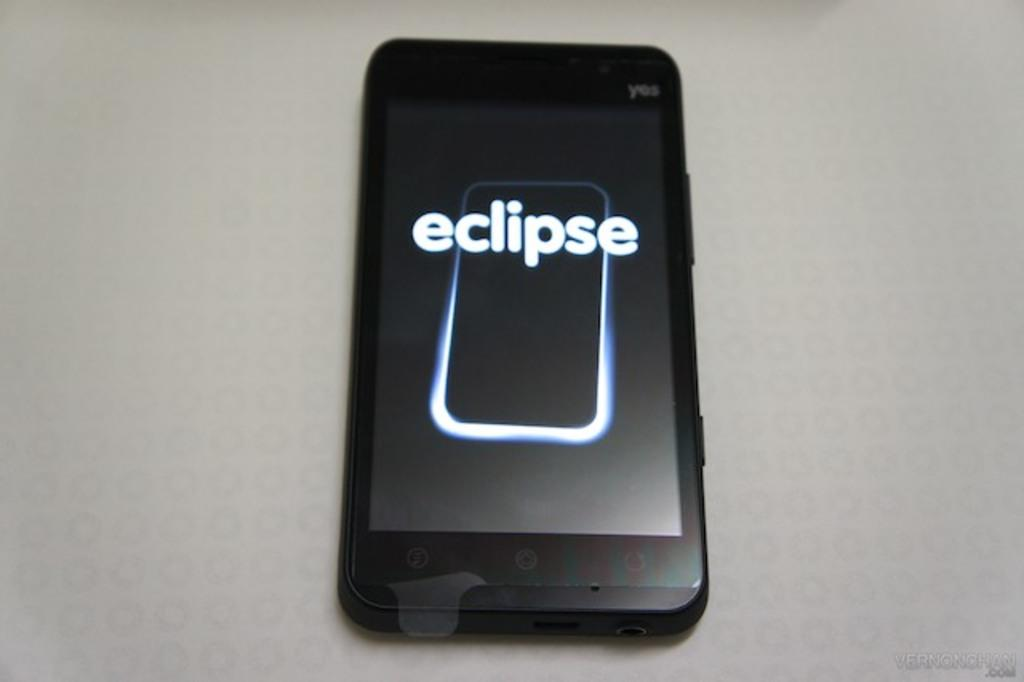Provide a one-sentence caption for the provided image. An Eclipse brand cellphone sitting on a white table. 